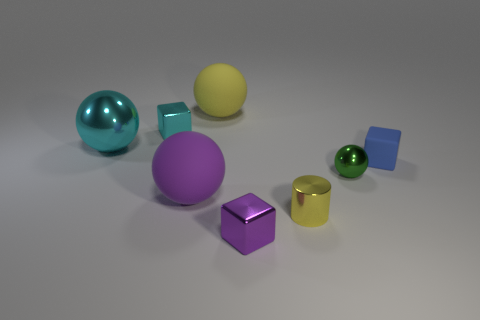Are there any patterns or textures visible on the surface where the objects are placed? The surface is quite smooth without any distinct patterns or textures; it has a uniform, matte-finish look, serving as a neutral background for the objects. 